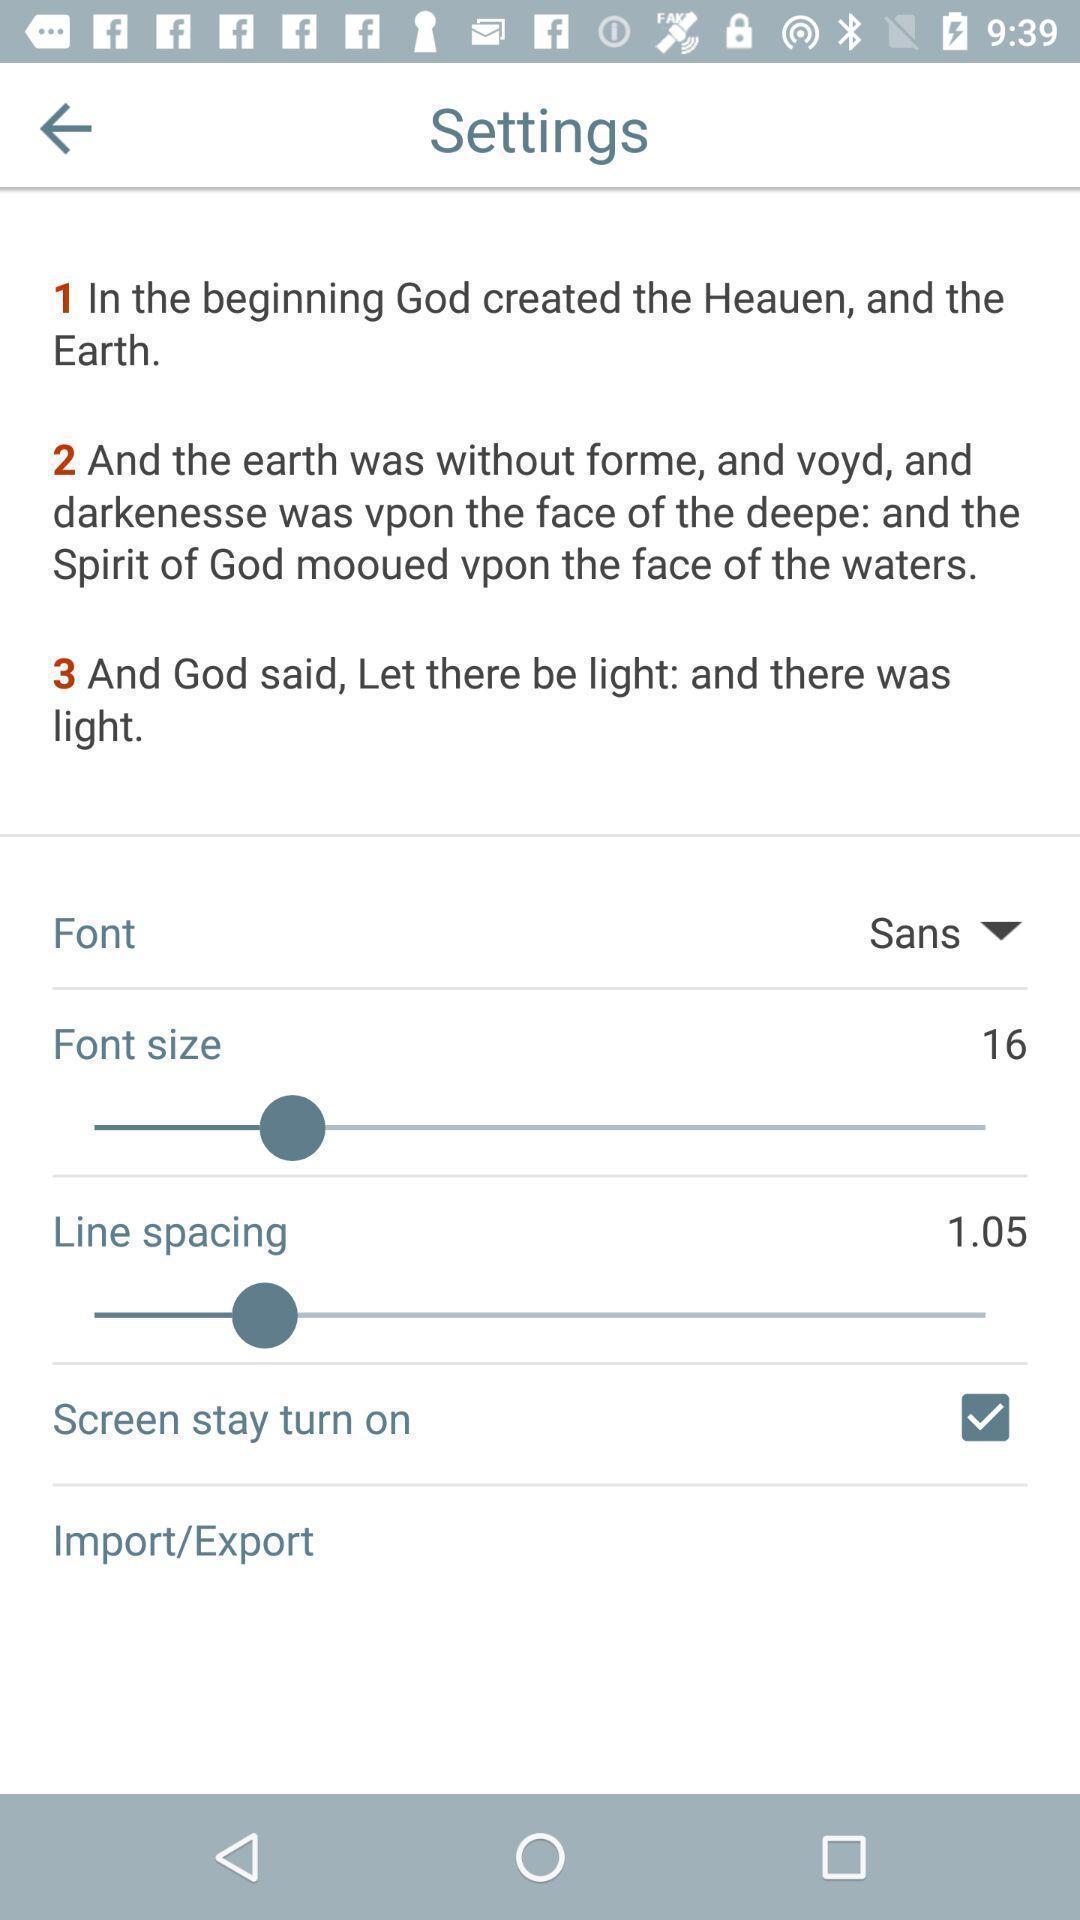Describe the visual elements of this screenshot. Settings related to a religion based app. 